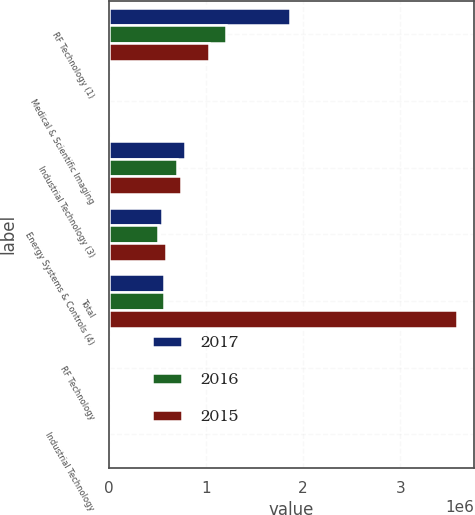<chart> <loc_0><loc_0><loc_500><loc_500><stacked_bar_chart><ecel><fcel>RF Technology (1)<fcel>Medical & Scientific Imaging<fcel>Industrial Technology (3)<fcel>Energy Systems & Controls (4)<fcel>Total<fcel>RF Technology<fcel>Industrial Technology<nl><fcel>2017<fcel>1.86213e+06<fcel>72<fcel>783707<fcel>551289<fcel>569517<fcel>61.1<fcel>50.6<nl><fcel>2016<fcel>1.21026e+06<fcel>73.2<fcel>706625<fcel>510223<fcel>569517<fcel>56.7<fcel>50.6<nl><fcel>2015<fcel>1.03395e+06<fcel>74<fcel>745381<fcel>587745<fcel>3.5824e+06<fcel>53.4<fcel>49.8<nl></chart> 